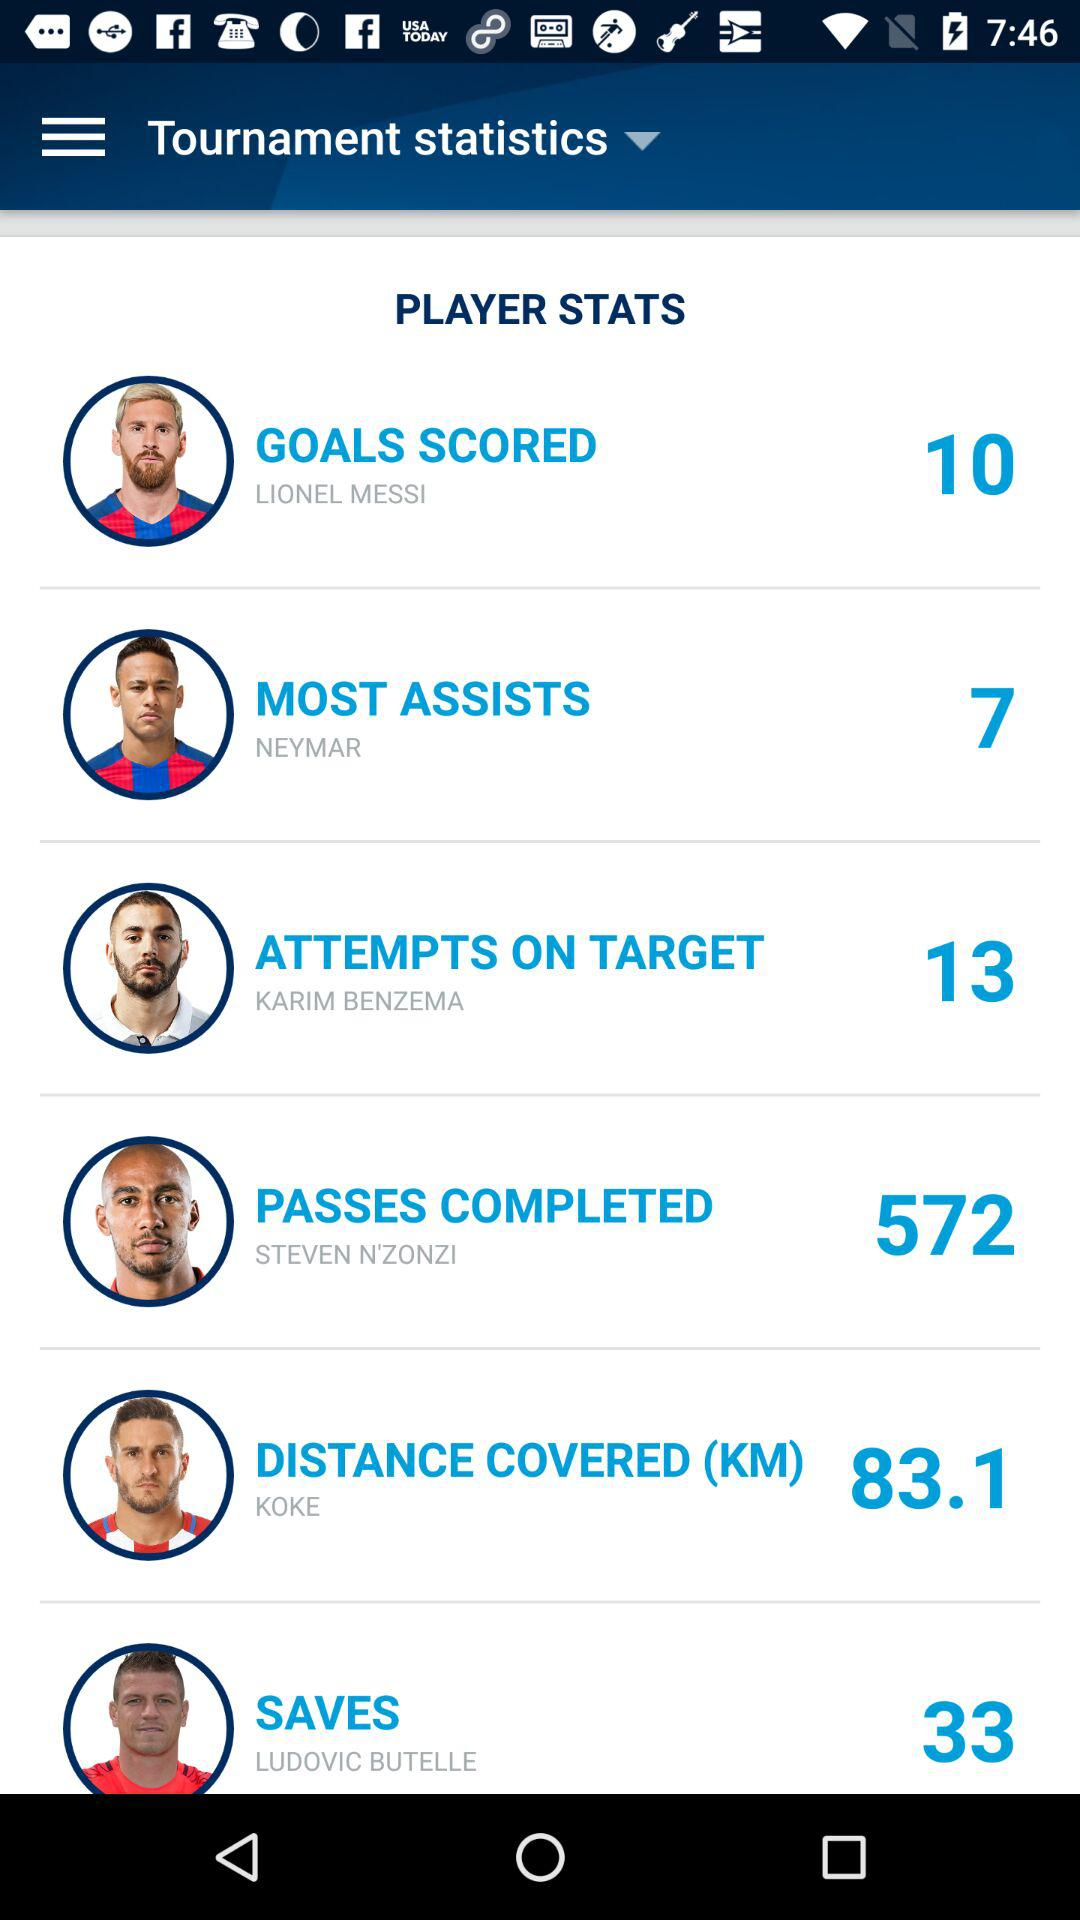How much distance is covered by Koke? The distance covered by Koke is 83.1 kilometres. 